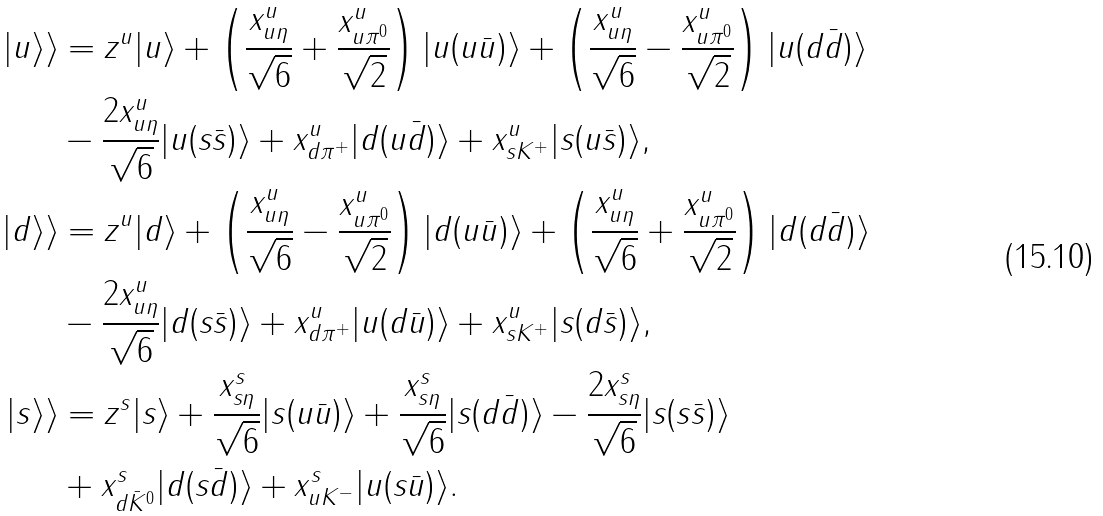<formula> <loc_0><loc_0><loc_500><loc_500>| u \rangle \rangle & = z ^ { u } | u \rangle + \left ( \frac { x ^ { u } _ { u \eta } } { \sqrt { 6 } } + \frac { x ^ { u } _ { u \pi ^ { 0 } } } { \sqrt { 2 } } \right ) | u ( u \bar { u } ) \rangle + \left ( \frac { x ^ { u } _ { u \eta } } { \sqrt { 6 } } - \frac { x ^ { u } _ { u \pi ^ { 0 } } } { \sqrt { 2 } } \right ) | u ( d \bar { d } ) \rangle \\ & - \frac { 2 x ^ { u } _ { u \eta } } { \sqrt { 6 } } | u ( s \bar { s } ) \rangle + x ^ { u } _ { d \pi ^ { + } } | d ( u \bar { d } ) \rangle + x ^ { u } _ { s K ^ { + } } | s ( u \bar { s } ) \rangle , \\ | d \rangle \rangle & = z ^ { u } | d \rangle + \left ( \frac { x ^ { u } _ { u \eta } } { \sqrt { 6 } } - \frac { x ^ { u } _ { u \pi ^ { 0 } } } { \sqrt { 2 } } \right ) | d ( u \bar { u } ) \rangle + \left ( \frac { x ^ { u } _ { u \eta } } { \sqrt { 6 } } + \frac { x ^ { u } _ { u \pi ^ { 0 } } } { \sqrt { 2 } } \right ) | d ( d \bar { d } ) \rangle \\ & - \frac { 2 x ^ { u } _ { u \eta } } { \sqrt { 6 } } | d ( s \bar { s } ) \rangle + x ^ { u } _ { d \pi ^ { + } } | u ( d \bar { u } ) \rangle + x ^ { u } _ { s K ^ { + } } | s ( d \bar { s } ) \rangle , \\ | s \rangle \rangle & = z ^ { s } | s \rangle + \frac { x ^ { s } _ { s \eta } } { \sqrt { 6 } } | s ( u \bar { u } ) \rangle + \frac { x ^ { s } _ { s \eta } } { \sqrt { 6 } } | s ( d \bar { d } ) \rangle - \frac { 2 x ^ { s } _ { s \eta } } { \sqrt { 6 } } | s ( s \bar { s } ) \rangle \\ & + x ^ { s } _ { d \bar { K } ^ { 0 } } | d ( s \bar { d } ) \rangle + x ^ { s } _ { u K ^ { - } } | u ( s \bar { u } ) \rangle .</formula> 